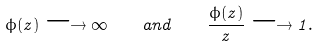Convert formula to latex. <formula><loc_0><loc_0><loc_500><loc_500>\phi ( z ) \longrightarrow \infty \quad a n d \quad \frac { \phi ( z ) } { z } \longrightarrow 1 .</formula> 